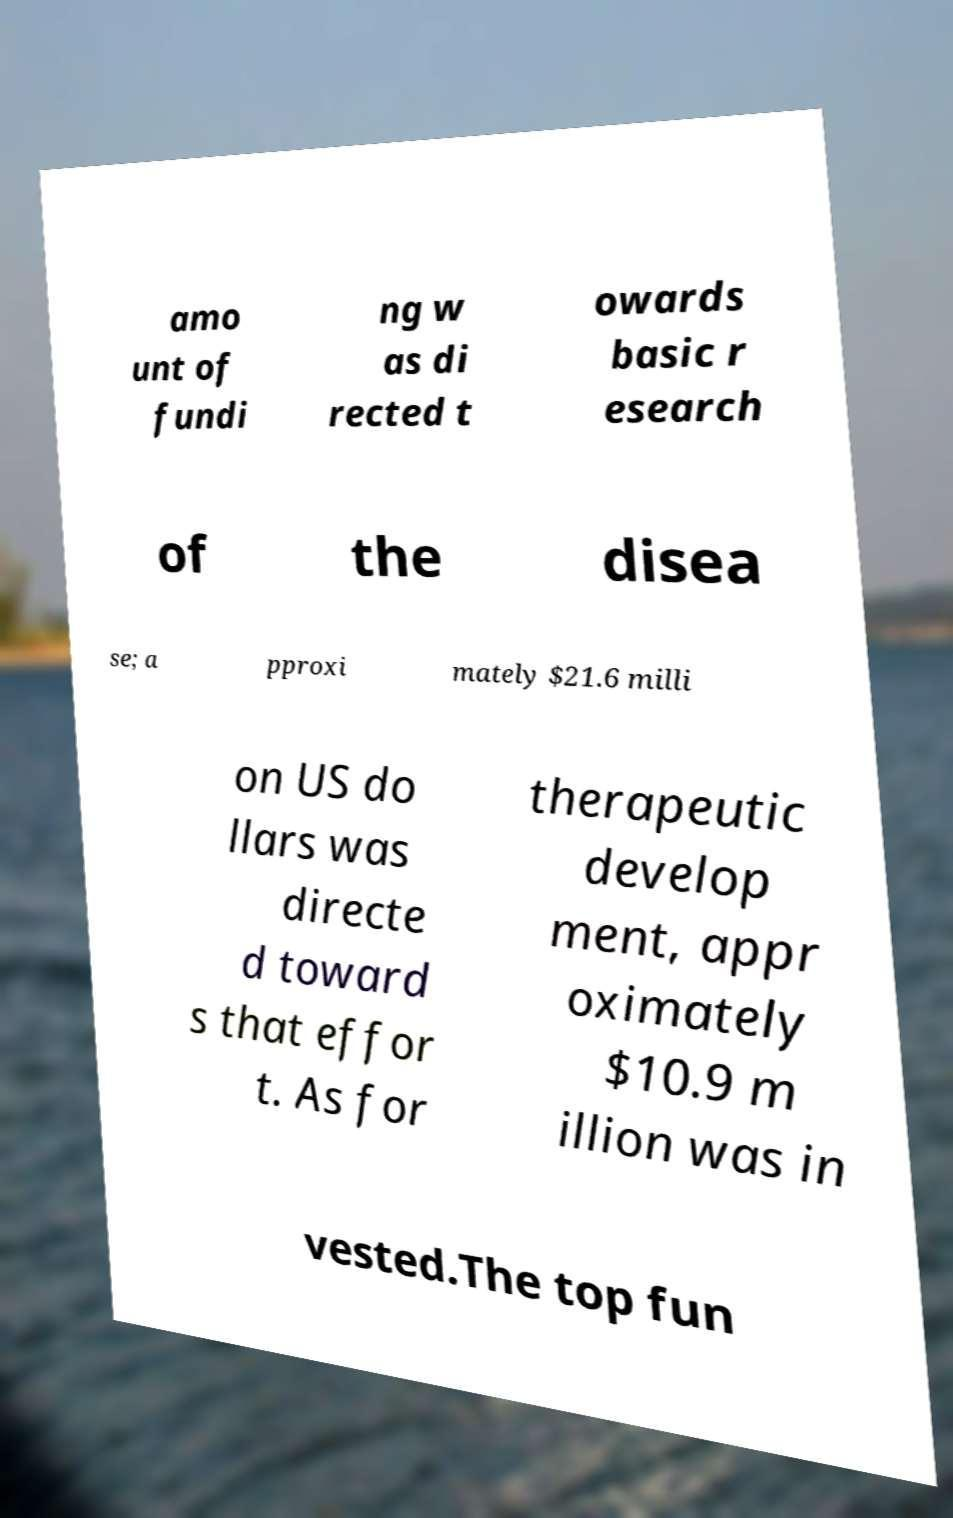Please identify and transcribe the text found in this image. amo unt of fundi ng w as di rected t owards basic r esearch of the disea se; a pproxi mately $21.6 milli on US do llars was directe d toward s that effor t. As for therapeutic develop ment, appr oximately $10.9 m illion was in vested.The top fun 